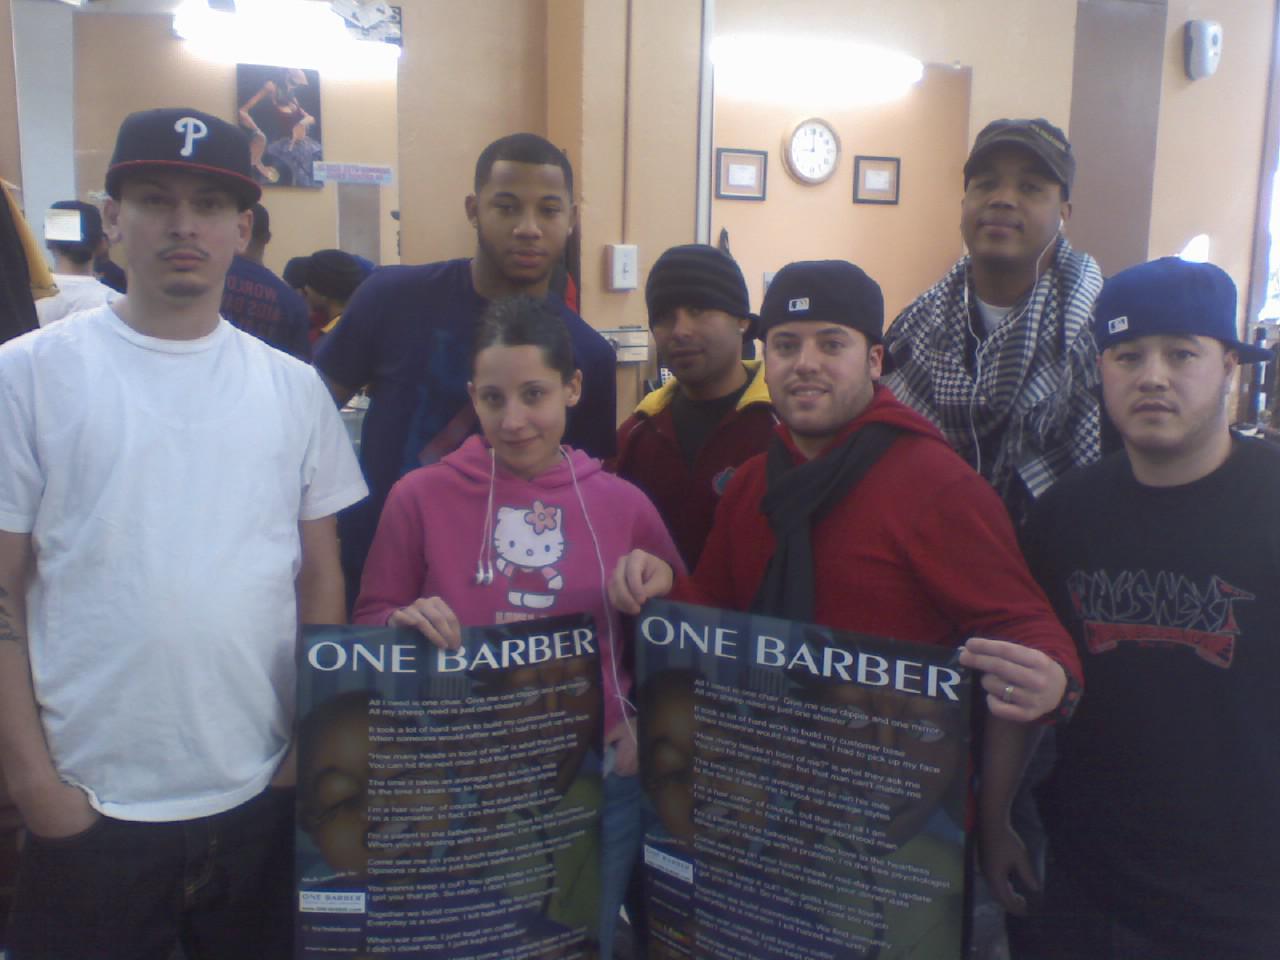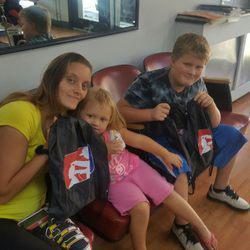The first image is the image on the left, the second image is the image on the right. Examine the images to the left and right. Is the description "In the center of one of the images there is a man with a beard sitting in a barber's chair surrounded by people." accurate? Answer yes or no. No. The first image is the image on the left, the second image is the image on the right. Assess this claim about the two images: "In at least one image there are four people in black shirts.". Correct or not? Answer yes or no. No. 